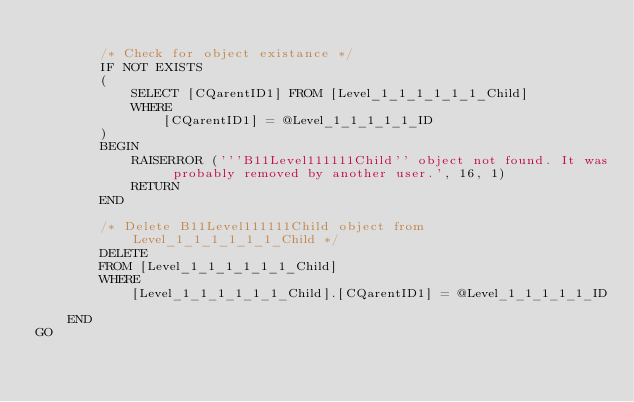Convert code to text. <code><loc_0><loc_0><loc_500><loc_500><_SQL_>
        /* Check for object existance */
        IF NOT EXISTS
        (
            SELECT [CQarentID1] FROM [Level_1_1_1_1_1_1_Child]
            WHERE
                [CQarentID1] = @Level_1_1_1_1_1_ID
        )
        BEGIN
            RAISERROR ('''B11Level111111Child'' object not found. It was probably removed by another user.', 16, 1)
            RETURN
        END

        /* Delete B11Level111111Child object from Level_1_1_1_1_1_1_Child */
        DELETE
        FROM [Level_1_1_1_1_1_1_Child]
        WHERE
            [Level_1_1_1_1_1_1_Child].[CQarentID1] = @Level_1_1_1_1_1_ID

    END
GO
</code> 